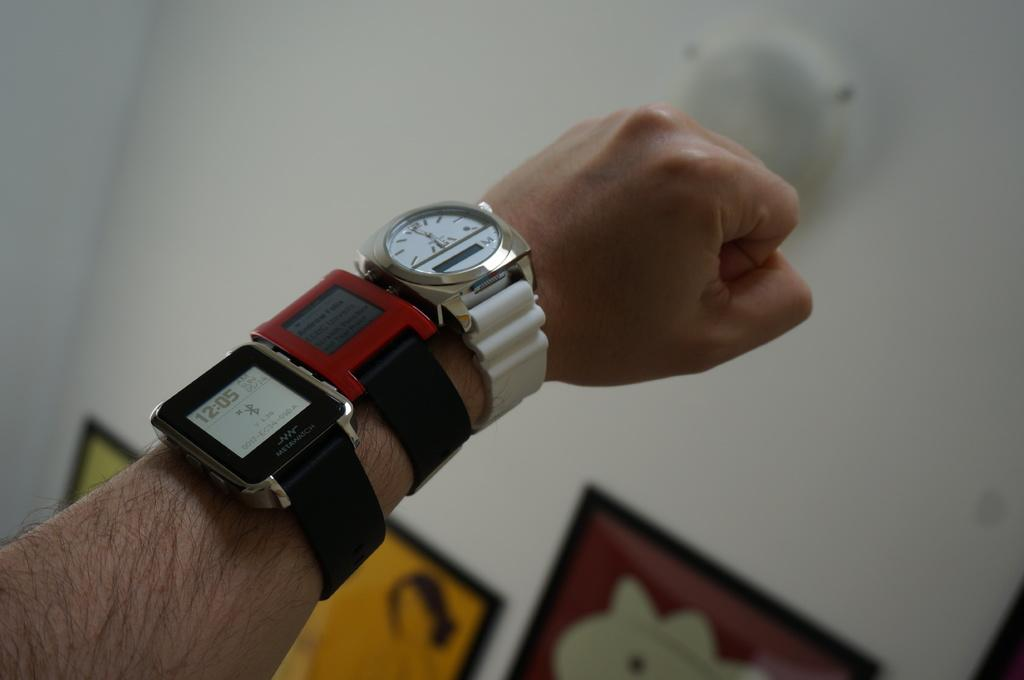<image>
Render a clear and concise summary of the photo. A man is wearing three watches and one of them says 12:05. 